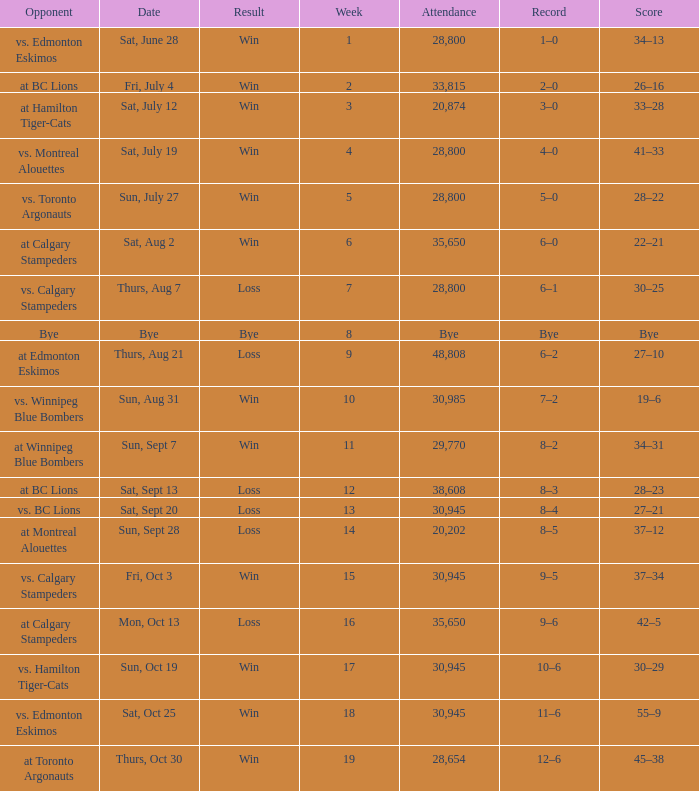What was the record the the match against vs. calgary stampeders before week 15? 6–1. 